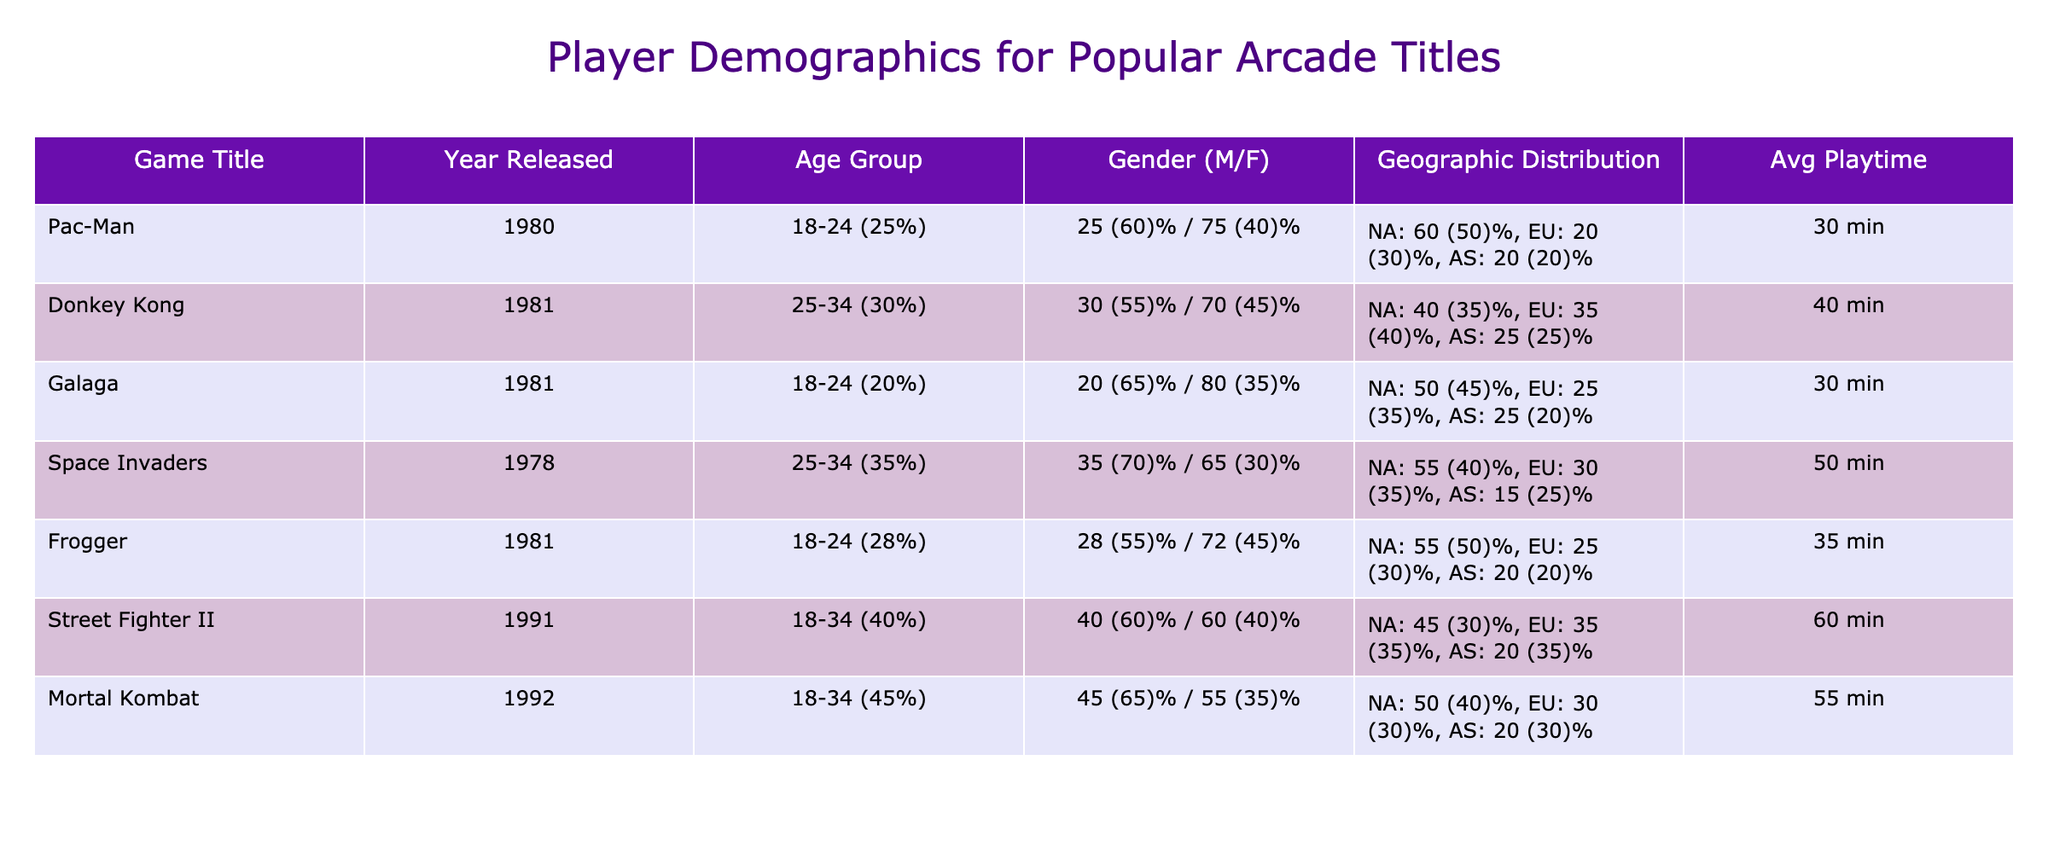What is the average playtime for Pac-Man? The playtime for Pac-Man is directly listed in the table under the "Avg Playtime" column, which shows it as 30 minutes.
Answer: 30 min Which age group has the highest percentage of players for Space Invaders? According to the table, the age group for Space Invaders is 25-34 (35%). This is the highest percentage compared to the percentage breakdown for other games.
Answer: 25-34 (35%) Does Frogger have a higher percentage of male players than female players? The gender breakdown for Frogger shows 55% male and 45% female. Since 55% is greater than 45%, the statement is true.
Answer: Yes What is the combined percentage of North America and Europe players for Mortal Kombat? For Mortal Kombat, the geographic distribution shows 50% for North America and 30% for Europe. Adding these two gives 50 + 30 = 80%.
Answer: 80% Which game has the highest average playtime, and how much is it? From the "Avg Playtime" column, we can see Mortal Kombat has the highest average playtime at 55 minutes compared to others.
Answer: Mortal Kombat, 55 min Does any game have more than 70% female players, and if so, which game is it? Looking at the gender distribution, Galaga has 35% female players, and the highest for females is Frogger at 45%, which do not exceed 70%. Hence, no game has than 70% female players.
Answer: No What is the difference in average playtime between Street Fighter II and Pac-Man? The average playtime for Street Fighter II is 60 minutes and for Pac-Man is 30 minutes. The difference is 60 - 30 = 30 minutes.
Answer: 30 min Which game has the smallest geographic distribution for Asia? Checking the geographic distribution for Asia, we find that Space Invaders has the smallest percentage at 25%.
Answer: Space Invaders In which geographic region does Donkey Kong have the highest distribution? The table indicates that Donkey Kong has the highest percentage distribution in North America at 40%.
Answer: North America 